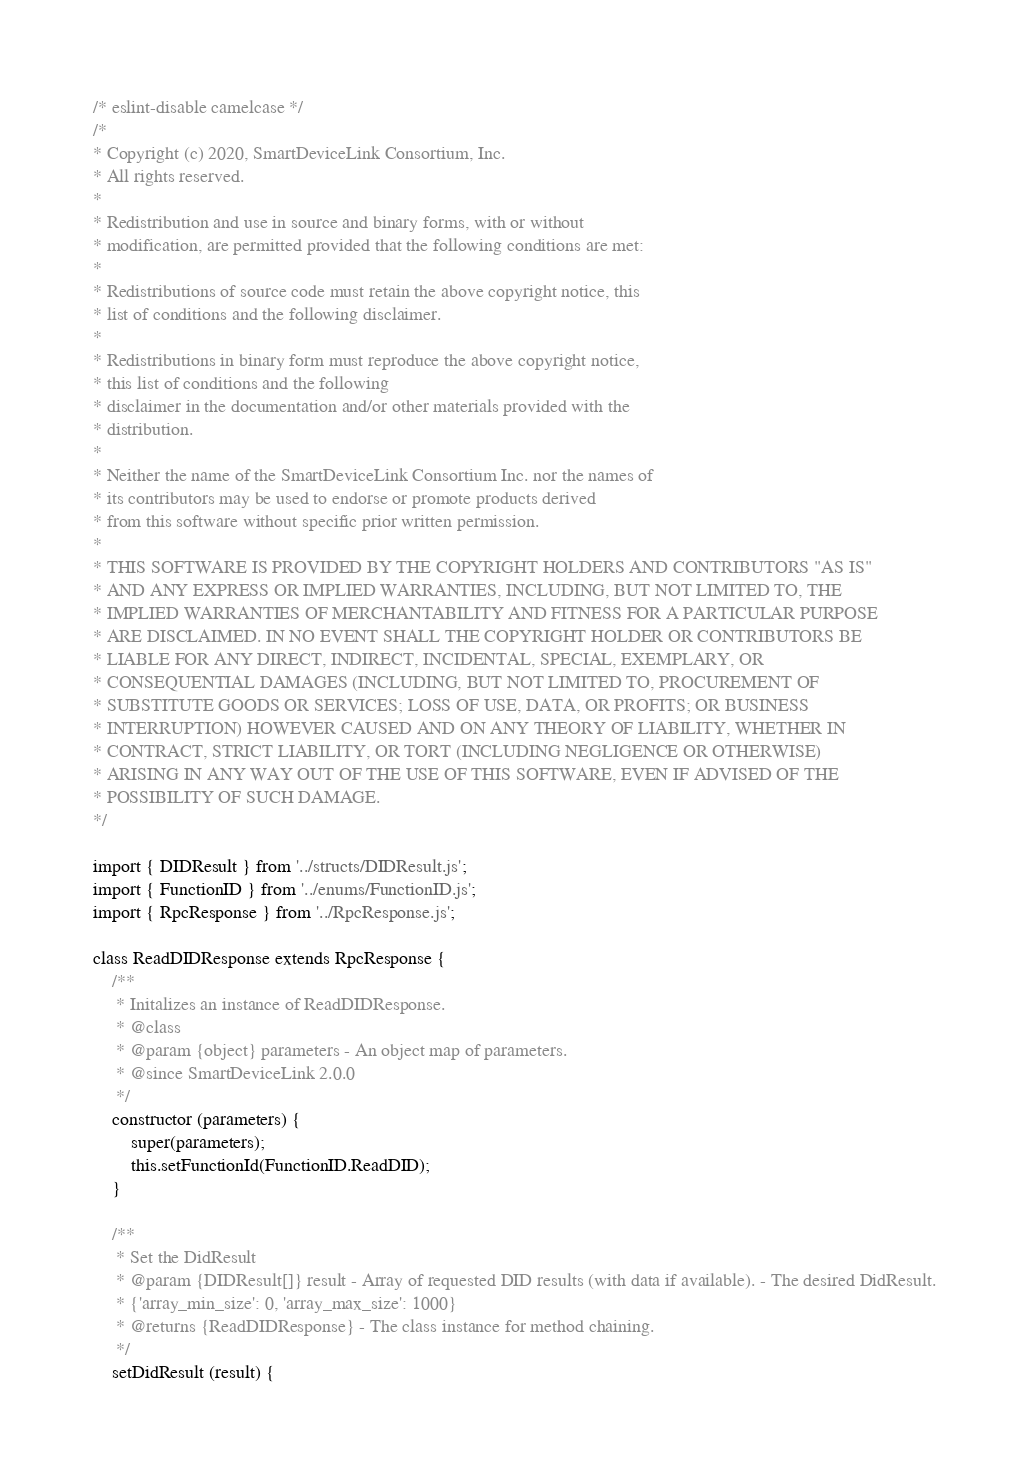Convert code to text. <code><loc_0><loc_0><loc_500><loc_500><_JavaScript_>/* eslint-disable camelcase */
/*
* Copyright (c) 2020, SmartDeviceLink Consortium, Inc.
* All rights reserved.
*
* Redistribution and use in source and binary forms, with or without
* modification, are permitted provided that the following conditions are met:
*
* Redistributions of source code must retain the above copyright notice, this
* list of conditions and the following disclaimer.
*
* Redistributions in binary form must reproduce the above copyright notice,
* this list of conditions and the following
* disclaimer in the documentation and/or other materials provided with the
* distribution.
*
* Neither the name of the SmartDeviceLink Consortium Inc. nor the names of
* its contributors may be used to endorse or promote products derived
* from this software without specific prior written permission.
*
* THIS SOFTWARE IS PROVIDED BY THE COPYRIGHT HOLDERS AND CONTRIBUTORS "AS IS"
* AND ANY EXPRESS OR IMPLIED WARRANTIES, INCLUDING, BUT NOT LIMITED TO, THE
* IMPLIED WARRANTIES OF MERCHANTABILITY AND FITNESS FOR A PARTICULAR PURPOSE
* ARE DISCLAIMED. IN NO EVENT SHALL THE COPYRIGHT HOLDER OR CONTRIBUTORS BE
* LIABLE FOR ANY DIRECT, INDIRECT, INCIDENTAL, SPECIAL, EXEMPLARY, OR
* CONSEQUENTIAL DAMAGES (INCLUDING, BUT NOT LIMITED TO, PROCUREMENT OF
* SUBSTITUTE GOODS OR SERVICES; LOSS OF USE, DATA, OR PROFITS; OR BUSINESS
* INTERRUPTION) HOWEVER CAUSED AND ON ANY THEORY OF LIABILITY, WHETHER IN
* CONTRACT, STRICT LIABILITY, OR TORT (INCLUDING NEGLIGENCE OR OTHERWISE)
* ARISING IN ANY WAY OUT OF THE USE OF THIS SOFTWARE, EVEN IF ADVISED OF THE
* POSSIBILITY OF SUCH DAMAGE.
*/

import { DIDResult } from '../structs/DIDResult.js';
import { FunctionID } from '../enums/FunctionID.js';
import { RpcResponse } from '../RpcResponse.js';

class ReadDIDResponse extends RpcResponse {
    /**
     * Initalizes an instance of ReadDIDResponse.
     * @class
     * @param {object} parameters - An object map of parameters.
     * @since SmartDeviceLink 2.0.0
     */
    constructor (parameters) {
        super(parameters);
        this.setFunctionId(FunctionID.ReadDID);
    }

    /**
     * Set the DidResult
     * @param {DIDResult[]} result - Array of requested DID results (with data if available). - The desired DidResult.
     * {'array_min_size': 0, 'array_max_size': 1000}
     * @returns {ReadDIDResponse} - The class instance for method chaining.
     */
    setDidResult (result) {</code> 